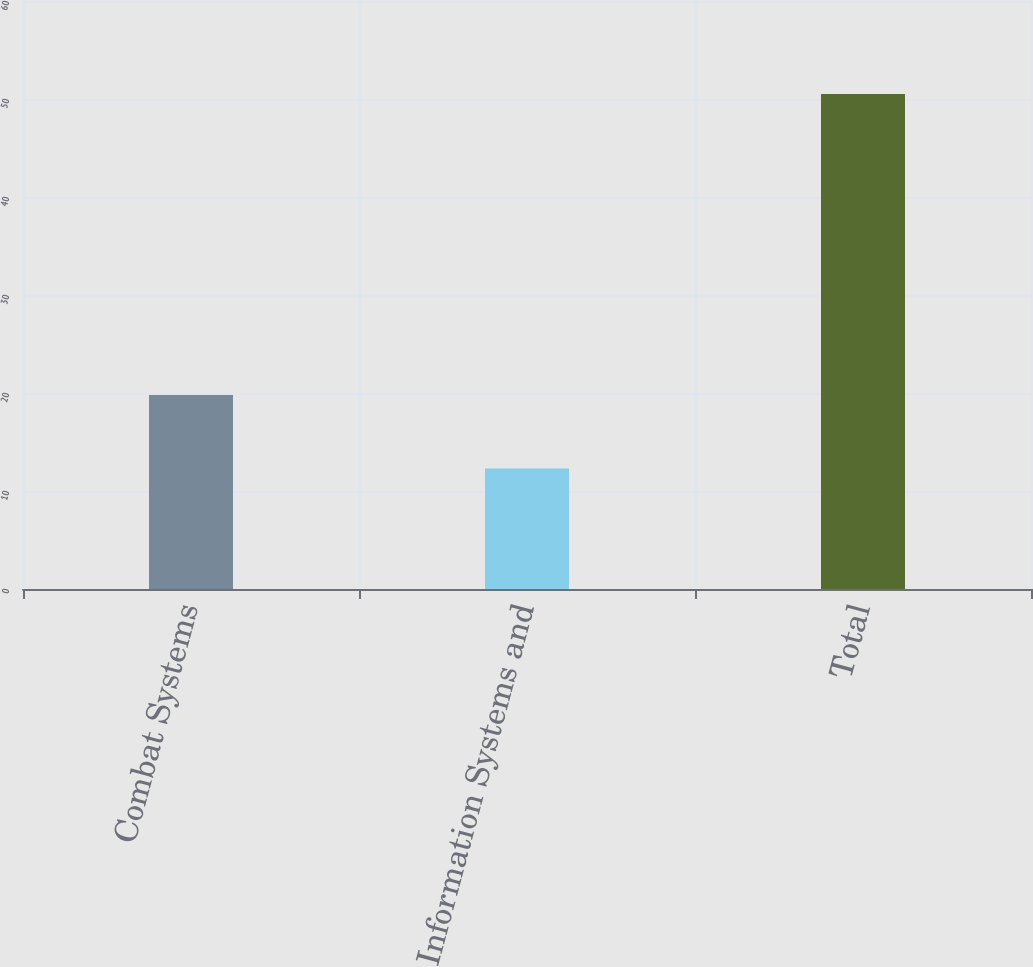Convert chart. <chart><loc_0><loc_0><loc_500><loc_500><bar_chart><fcel>Combat Systems<fcel>Information Systems and<fcel>Total<nl><fcel>19.8<fcel>12.3<fcel>50.5<nl></chart> 